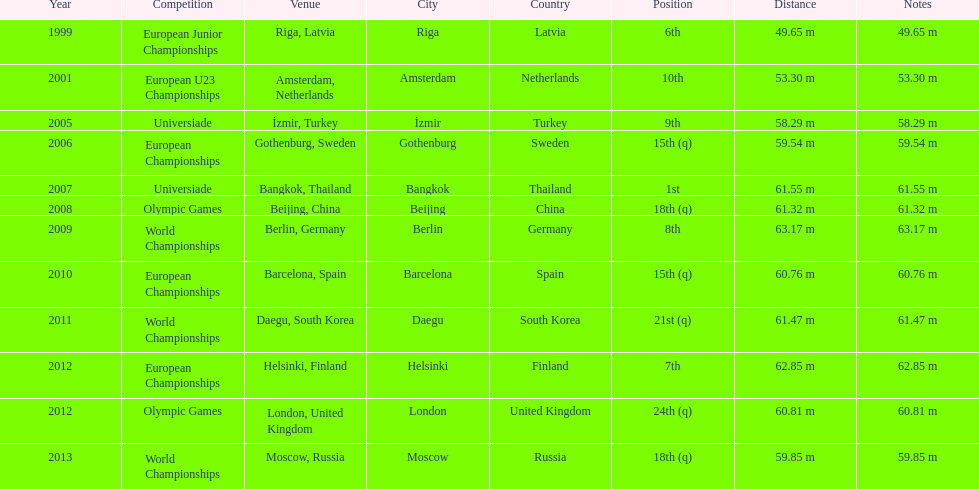Name two events in which mayer competed before he won the bangkok universiade. European Championships, Universiade. 